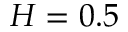Convert formula to latex. <formula><loc_0><loc_0><loc_500><loc_500>H = 0 . 5</formula> 